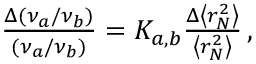<formula> <loc_0><loc_0><loc_500><loc_500>\begin{array} { r } { \frac { \Delta ( \nu _ { a } / \nu _ { b } ) } { ( \nu _ { a } / \nu _ { b } ) } = K _ { a , b } \frac { \Delta \left < r _ { N } ^ { 2 } \right > } { \left < r _ { N } ^ { 2 } \right > } \, , } \end{array}</formula> 